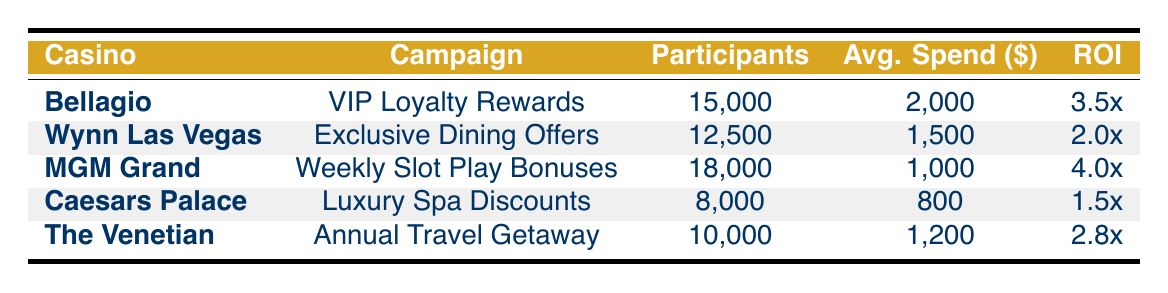What is the ROI of the "Luxury Spa Discounts" campaign? The ROI for the "Luxury Spa Discounts" campaign is listed directly in the table under the ROI column, which is 1.5x.
Answer: 1.5x Which campaign had the highest total participants? By reviewing the total participants for each campaign, "Weekly Slot Play Bonuses" from MGM Grand has the highest with 18,000 participants.
Answer: 18,000 What is the average spend per participant for the "VIP Loyalty Rewards" campaign? The table shows the average spend per participant for the "VIP Loyalty Rewards" campaign is $2,000 as provided in the respective column.
Answer: $2,000 Which casino had the lowest customer retention rate? By analyzing the customer retention rates for each casino, Caesars Palace has the lowest rate at 0.60.
Answer: Caesars Palace What is the total cost for the "Annual Travel Getaway" campaign? The total cost for the "Annual Travel Getaway" campaign can be found in the table, which indicates it is $350,000.
Answer: $350,000 How much revenue did the MGM Grand generate per participant in the "Weekly Slot Play Bonuses" campaign? The average spend per participant for MGM Grand's campaign is $1,000, and with a redemption rate of 0.40, the effective revenue would be calculated as $1,000 * 0.40 = $400.
Answer: $400 What campaign had a higher redemption rate, "VIP Loyalty Rewards" or "Exclusive Dining Offers"? Comparing the redemption rates, the "VIP Loyalty Rewards" campaign has a rate of 0.25 while "Exclusive Dining Offers" has a rate of 0.15, so "VIP Loyalty Rewards" has a higher rate.
Answer: VIP Loyalty Rewards If you sum the average spend of all campaigns, what is the total? The average spends from all campaigns are $2,000, $1,500, $1,000, $800, and $1,200. Summing these gives $2,000 + $1,500 + $1,000 + $800 + $1,200 = $6,500.
Answer: $6,500 Is there a campaign with a return on investment greater than 3.0? By examining the ROI column, "VIP Loyalty Rewards" has an ROI of 3.5 and "Weekly Slot Play Bonuses" has 4.0, both greater than 3.0, therefore the answer is yes.
Answer: Yes What is the average customer retention rate across all campaigns? The customer retention rates are 0.75, 0.70, 0.80, 0.60, and 0.65. Summing these gives 3.60, and dividing by the number of campaigns (5) gives an average of 3.60/5 = 0.72.
Answer: 0.72 